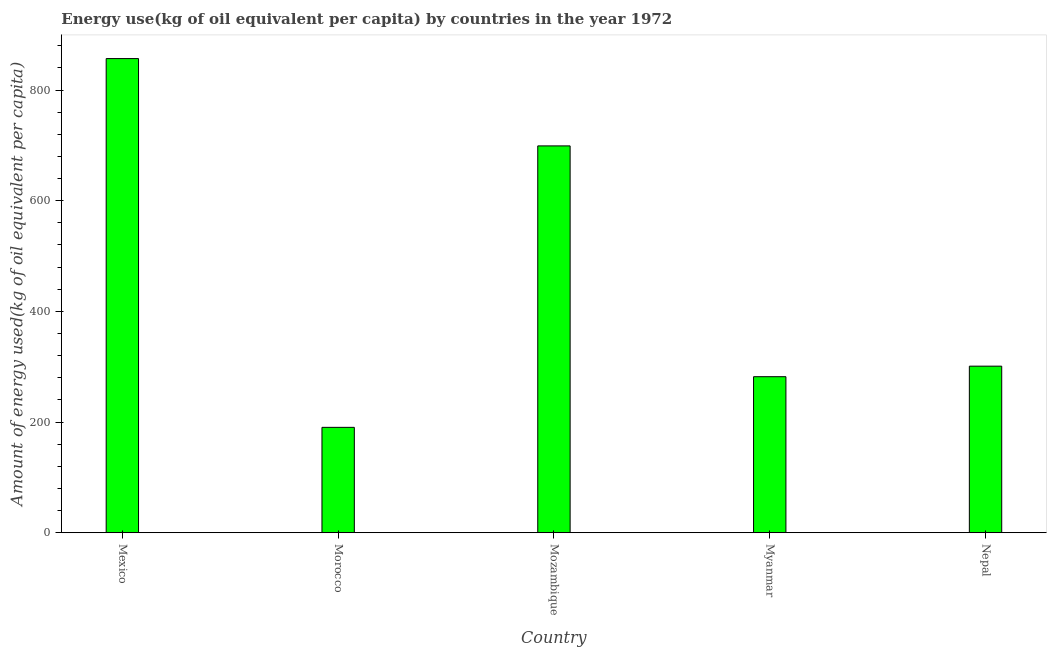Does the graph contain any zero values?
Your response must be concise. No. Does the graph contain grids?
Offer a terse response. No. What is the title of the graph?
Offer a terse response. Energy use(kg of oil equivalent per capita) by countries in the year 1972. What is the label or title of the Y-axis?
Offer a terse response. Amount of energy used(kg of oil equivalent per capita). What is the amount of energy used in Mozambique?
Provide a succinct answer. 699.02. Across all countries, what is the maximum amount of energy used?
Offer a very short reply. 856.81. Across all countries, what is the minimum amount of energy used?
Ensure brevity in your answer.  190.39. In which country was the amount of energy used minimum?
Your response must be concise. Morocco. What is the sum of the amount of energy used?
Your response must be concise. 2329.13. What is the difference between the amount of energy used in Morocco and Mozambique?
Give a very brief answer. -508.63. What is the average amount of energy used per country?
Ensure brevity in your answer.  465.82. What is the median amount of energy used?
Provide a short and direct response. 300.97. In how many countries, is the amount of energy used greater than 520 kg?
Ensure brevity in your answer.  2. What is the ratio of the amount of energy used in Mexico to that in Nepal?
Ensure brevity in your answer.  2.85. Is the difference between the amount of energy used in Mexico and Morocco greater than the difference between any two countries?
Make the answer very short. Yes. What is the difference between the highest and the second highest amount of energy used?
Make the answer very short. 157.79. Is the sum of the amount of energy used in Mexico and Mozambique greater than the maximum amount of energy used across all countries?
Offer a terse response. Yes. What is the difference between the highest and the lowest amount of energy used?
Keep it short and to the point. 666.42. What is the Amount of energy used(kg of oil equivalent per capita) in Mexico?
Your answer should be compact. 856.81. What is the Amount of energy used(kg of oil equivalent per capita) in Morocco?
Offer a very short reply. 190.39. What is the Amount of energy used(kg of oil equivalent per capita) in Mozambique?
Keep it short and to the point. 699.02. What is the Amount of energy used(kg of oil equivalent per capita) of Myanmar?
Keep it short and to the point. 281.93. What is the Amount of energy used(kg of oil equivalent per capita) of Nepal?
Offer a very short reply. 300.97. What is the difference between the Amount of energy used(kg of oil equivalent per capita) in Mexico and Morocco?
Your answer should be very brief. 666.42. What is the difference between the Amount of energy used(kg of oil equivalent per capita) in Mexico and Mozambique?
Make the answer very short. 157.79. What is the difference between the Amount of energy used(kg of oil equivalent per capita) in Mexico and Myanmar?
Provide a succinct answer. 574.88. What is the difference between the Amount of energy used(kg of oil equivalent per capita) in Mexico and Nepal?
Your answer should be compact. 555.84. What is the difference between the Amount of energy used(kg of oil equivalent per capita) in Morocco and Mozambique?
Offer a very short reply. -508.63. What is the difference between the Amount of energy used(kg of oil equivalent per capita) in Morocco and Myanmar?
Offer a terse response. -91.54. What is the difference between the Amount of energy used(kg of oil equivalent per capita) in Morocco and Nepal?
Give a very brief answer. -110.58. What is the difference between the Amount of energy used(kg of oil equivalent per capita) in Mozambique and Myanmar?
Keep it short and to the point. 417.09. What is the difference between the Amount of energy used(kg of oil equivalent per capita) in Mozambique and Nepal?
Provide a succinct answer. 398.05. What is the difference between the Amount of energy used(kg of oil equivalent per capita) in Myanmar and Nepal?
Give a very brief answer. -19.04. What is the ratio of the Amount of energy used(kg of oil equivalent per capita) in Mexico to that in Morocco?
Keep it short and to the point. 4.5. What is the ratio of the Amount of energy used(kg of oil equivalent per capita) in Mexico to that in Mozambique?
Make the answer very short. 1.23. What is the ratio of the Amount of energy used(kg of oil equivalent per capita) in Mexico to that in Myanmar?
Keep it short and to the point. 3.04. What is the ratio of the Amount of energy used(kg of oil equivalent per capita) in Mexico to that in Nepal?
Offer a terse response. 2.85. What is the ratio of the Amount of energy used(kg of oil equivalent per capita) in Morocco to that in Mozambique?
Your answer should be very brief. 0.27. What is the ratio of the Amount of energy used(kg of oil equivalent per capita) in Morocco to that in Myanmar?
Your answer should be very brief. 0.68. What is the ratio of the Amount of energy used(kg of oil equivalent per capita) in Morocco to that in Nepal?
Your answer should be very brief. 0.63. What is the ratio of the Amount of energy used(kg of oil equivalent per capita) in Mozambique to that in Myanmar?
Offer a terse response. 2.48. What is the ratio of the Amount of energy used(kg of oil equivalent per capita) in Mozambique to that in Nepal?
Keep it short and to the point. 2.32. What is the ratio of the Amount of energy used(kg of oil equivalent per capita) in Myanmar to that in Nepal?
Make the answer very short. 0.94. 